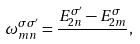<formula> <loc_0><loc_0><loc_500><loc_500>\omega ^ { \sigma \sigma ^ { \prime } } _ { m n } = \frac { E _ { 2 n } ^ { \sigma ^ { \prime } } - E _ { 2 m } ^ { \sigma } } { } ,</formula> 